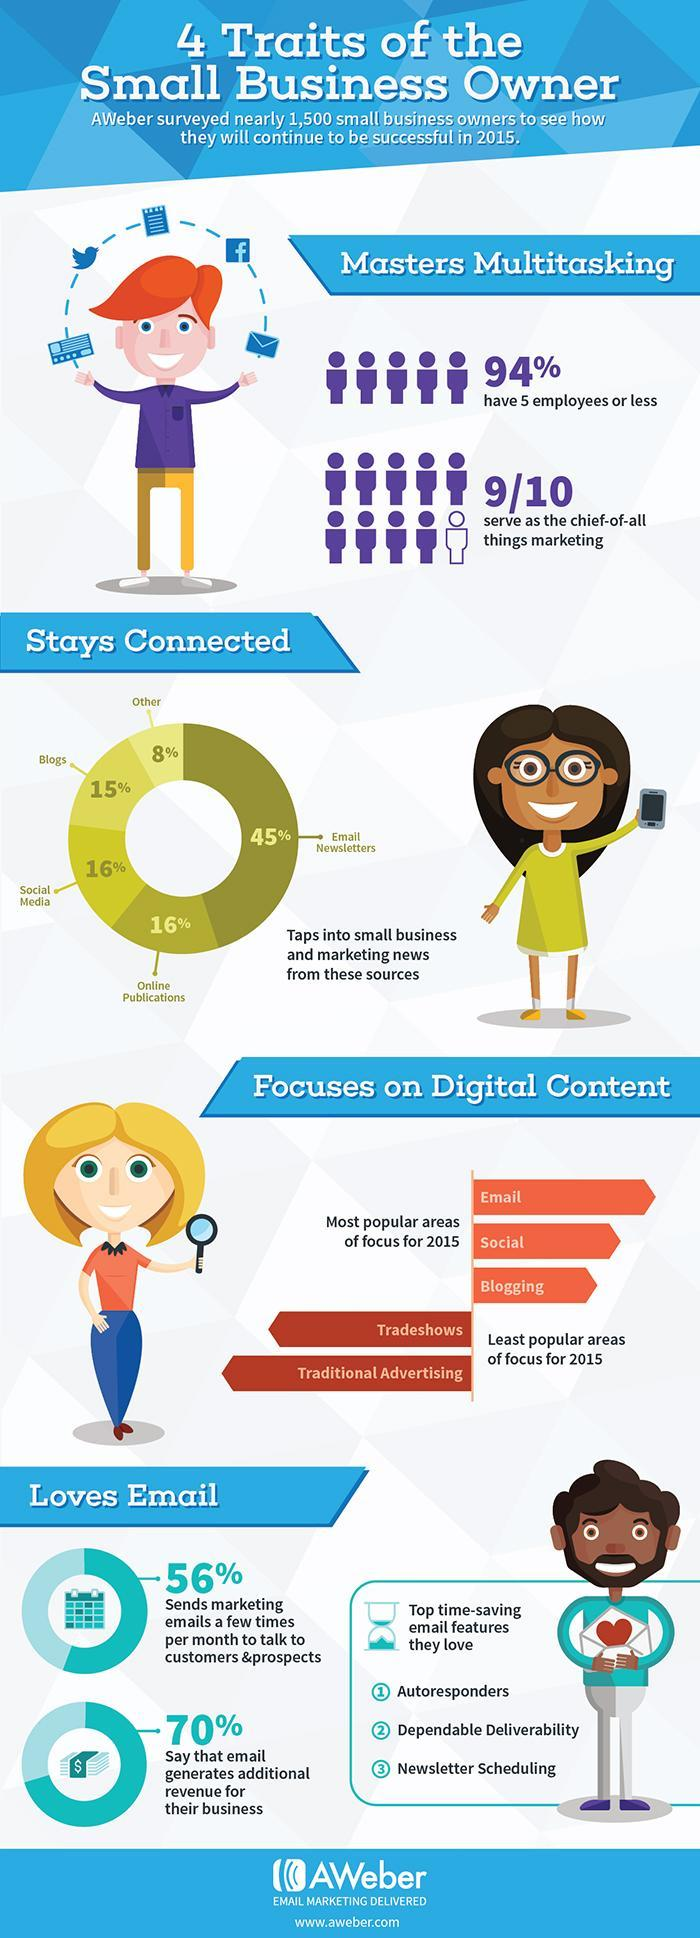what attribute of autoresponders in emails do people love
Answer the question with a short phrase. time-saving what percentage serve as the chief-of-all things marketing 90 What percentage has more than 5 employees 6 how many believe that email generates additional revenue 70% how much percentage do blogs and social media help to stay connected 31 